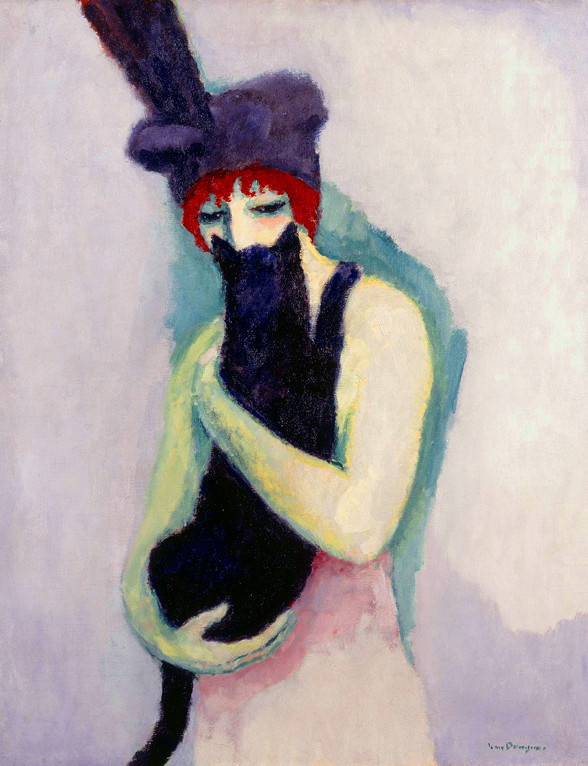What do you think is going on in this snapshot? The image presents a woman in a post-impressionist style, a genre known for its vivid colors and real-life subject matter. The woman is the central figure, cradling a black cat in her arms. She is adorned in a red hat, embellished with a black feather, adding a touch of elegance to her attire. A green shawl drapes over her shoulders, contrasting with the red of her hat. The background is a wash of pale purple, providing a calm backdrop to the vibrant colors of the woman and her cat. The overall composition is a portrait, focusing on the woman and her feline companion. 